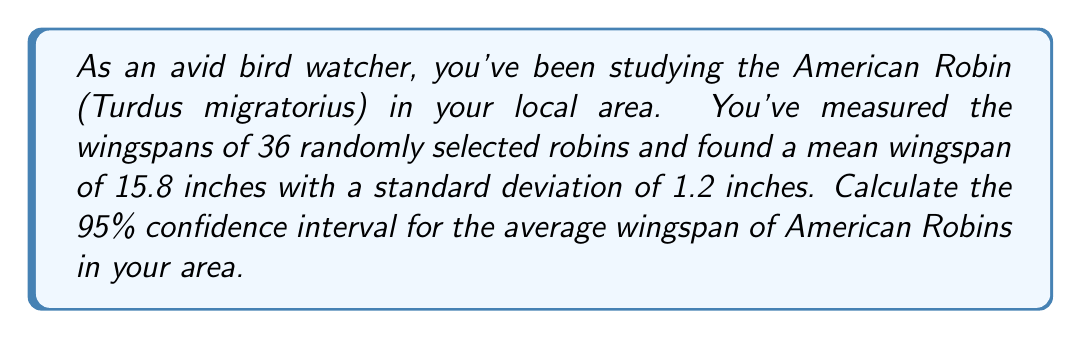Can you solve this math problem? Let's follow these steps to calculate the confidence interval:

1) We're given:
   - Sample size: $n = 36$
   - Sample mean: $\bar{x} = 15.8$ inches
   - Sample standard deviation: $s = 1.2$ inches
   - Confidence level: 95%

2) For a 95% confidence interval, we use a z-score of 1.96 (assuming normal distribution).

3) The formula for the confidence interval is:

   $$\bar{x} \pm z \cdot \frac{s}{\sqrt{n}}$$

4) Let's calculate the standard error:

   $$\frac{s}{\sqrt{n}} = \frac{1.2}{\sqrt{36}} = \frac{1.2}{6} = 0.2$$

5) Now, let's calculate the margin of error:

   $$1.96 \cdot 0.2 = 0.392$$

6) Finally, we can calculate the confidence interval:

   Lower bound: $15.8 - 0.392 = 15.408$
   Upper bound: $15.8 + 0.392 = 16.192$

7) Rounding to one decimal place for practical use:

   The 95% confidence interval is (15.4 inches, 16.2 inches)
Answer: (15.4 inches, 16.2 inches) 